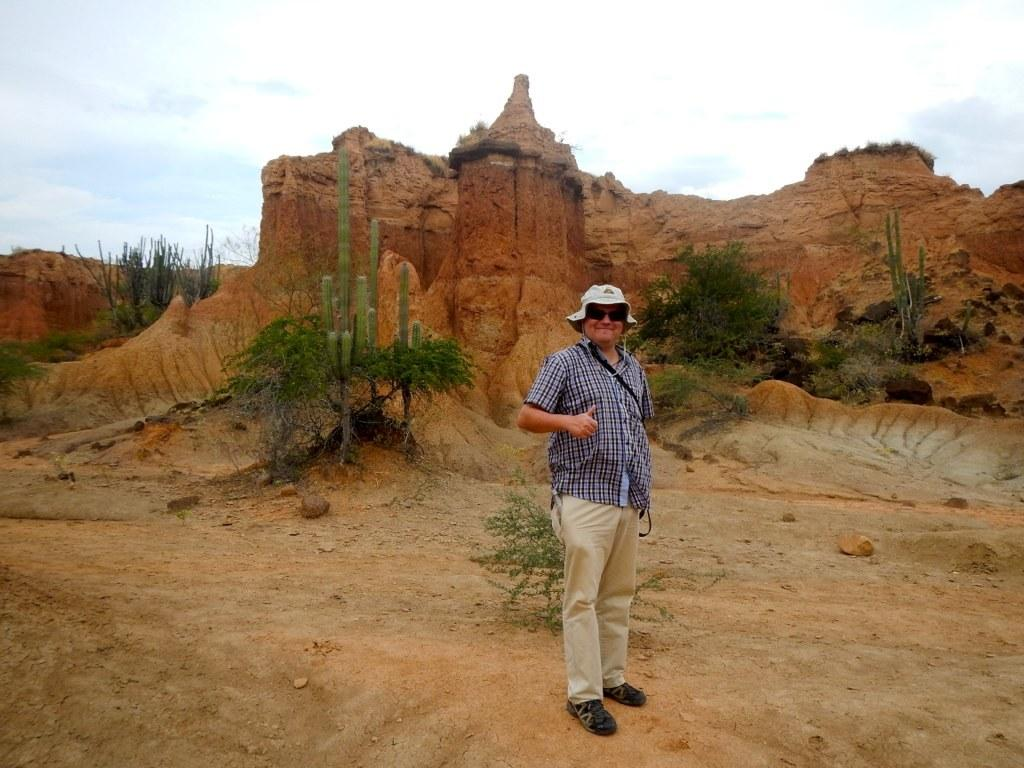Who or what is in the image? There is a person in the image. What is the person doing in the image? The person is standing in front of mounds. What can be seen on the mounds? There are cactus plants on the mounds. How many hands does the cactus have in the image? Cactus plants do not have hands; they have spines or needles. 